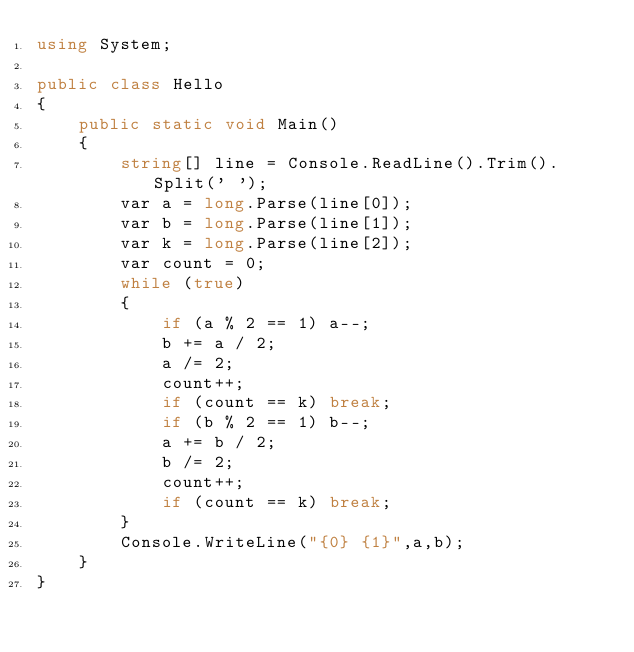Convert code to text. <code><loc_0><loc_0><loc_500><loc_500><_C#_>using System;

public class Hello
{
    public static void Main()
    {
        string[] line = Console.ReadLine().Trim().Split(' ');
        var a = long.Parse(line[0]);
        var b = long.Parse(line[1]);
        var k = long.Parse(line[2]);
        var count = 0;
        while (true)
        {
            if (a % 2 == 1) a--;
            b += a / 2;
            a /= 2;
            count++;
            if (count == k) break;
            if (b % 2 == 1) b--;
            a += b / 2;
            b /= 2;
            count++;
            if (count == k) break;
        }
        Console.WriteLine("{0} {1}",a,b);
    }
}
</code> 